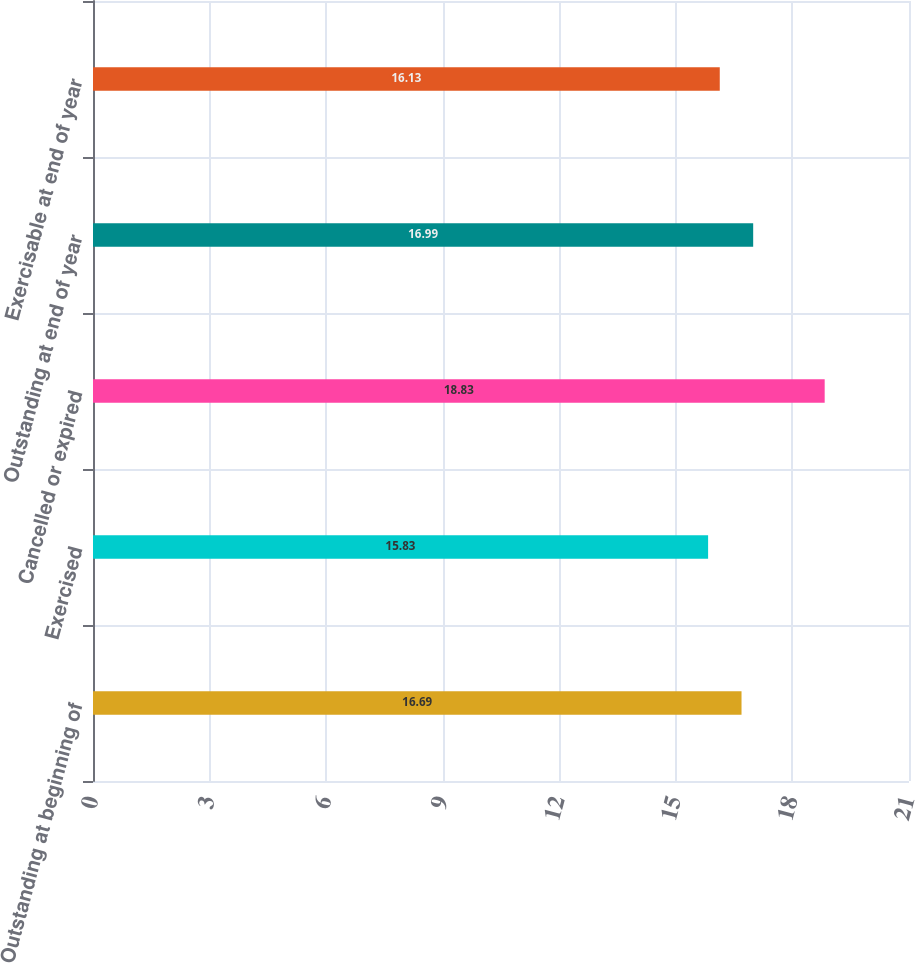Convert chart. <chart><loc_0><loc_0><loc_500><loc_500><bar_chart><fcel>Outstanding at beginning of<fcel>Exercised<fcel>Cancelled or expired<fcel>Outstanding at end of year<fcel>Exercisable at end of year<nl><fcel>16.69<fcel>15.83<fcel>18.83<fcel>16.99<fcel>16.13<nl></chart> 